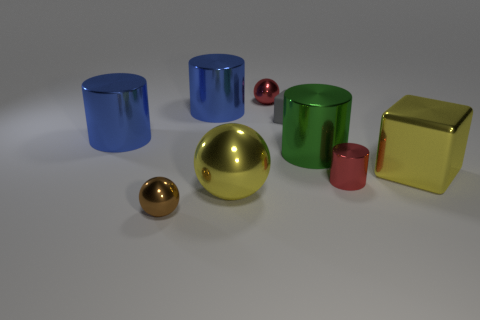There is a red thing that is behind the red cylinder; is it the same size as the gray thing?
Provide a succinct answer. Yes. Are there more large metal cylinders than tiny brown cylinders?
Give a very brief answer. Yes. How many big things are either blue objects or shiny cylinders?
Your answer should be compact. 3. How many other things are there of the same color as the large sphere?
Give a very brief answer. 1. How many big balls have the same material as the large cube?
Provide a short and direct response. 1. Do the cube that is to the left of the tiny metallic cylinder and the large ball have the same color?
Your answer should be compact. No. How many brown things are balls or rubber cubes?
Your answer should be compact. 1. Are there any other things that have the same material as the large green thing?
Provide a succinct answer. Yes. Does the blue object behind the gray rubber block have the same material as the yellow block?
Your answer should be very brief. Yes. What number of things are yellow objects or small metal objects on the right side of the green metal cylinder?
Offer a very short reply. 3. 